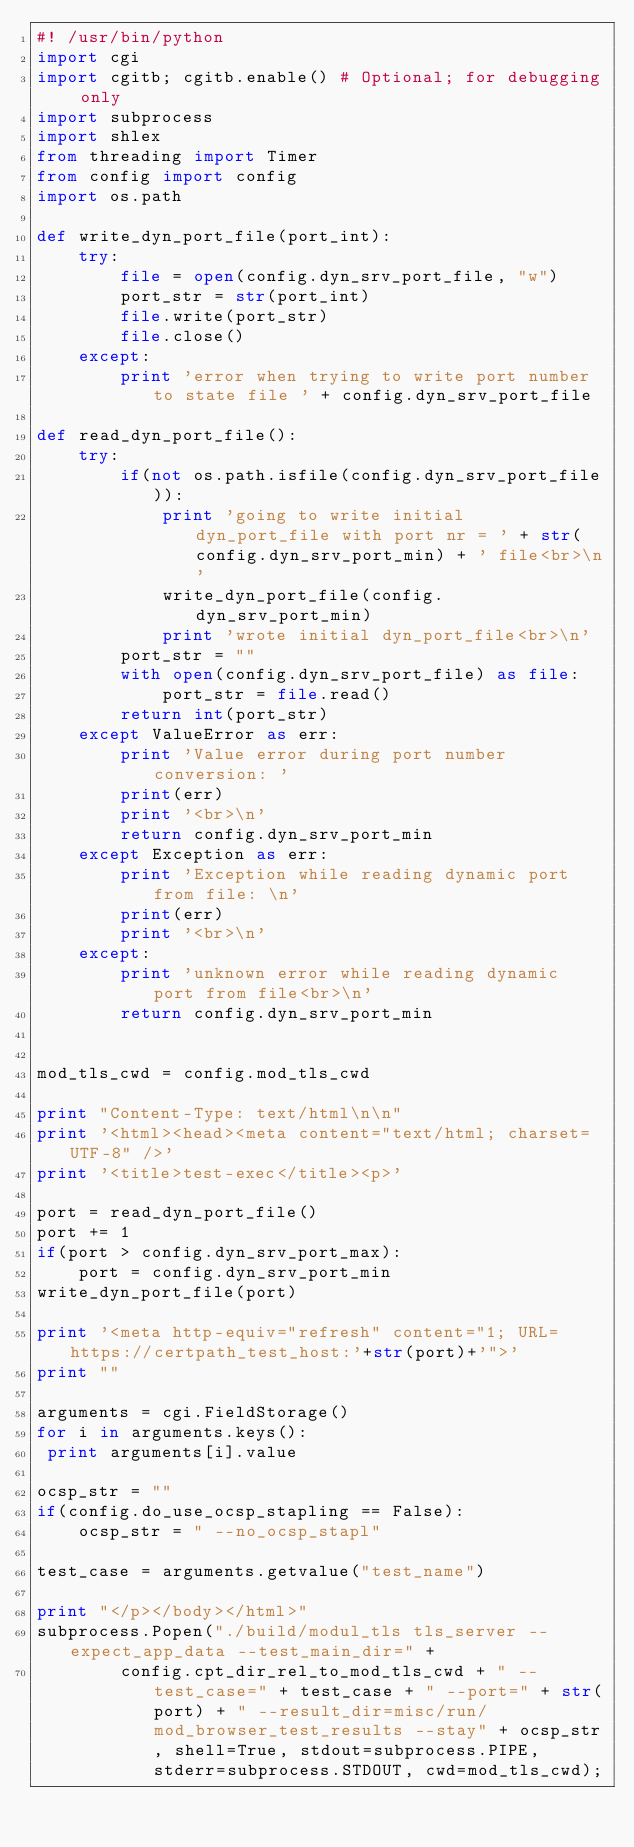<code> <loc_0><loc_0><loc_500><loc_500><_Python_>#! /usr/bin/python
import cgi
import cgitb; cgitb.enable() # Optional; for debugging only
import subprocess
import shlex
from threading import Timer
from config import config
import os.path

def write_dyn_port_file(port_int):
    try:
        file = open(config.dyn_srv_port_file, "w")
        port_str = str(port_int)
        file.write(port_str)
        file.close()
    except:
        print 'error when trying to write port number to state file ' + config.dyn_srv_port_file

def read_dyn_port_file():
    try:
        if(not os.path.isfile(config.dyn_srv_port_file)):
            print 'going to write initial dyn_port_file with port nr = ' + str(config.dyn_srv_port_min) + ' file<br>\n'
            write_dyn_port_file(config.dyn_srv_port_min)
            print 'wrote initial dyn_port_file<br>\n'
        port_str = ""
        with open(config.dyn_srv_port_file) as file:  
            port_str = file.read() 
        return int(port_str)
    except ValueError as err:
        print 'Value error during port number conversion: '
        print(err)
        print '<br>\n'
        return config.dyn_srv_port_min
    except Exception as err:
        print 'Exception while reading dynamic port from file: \n'
        print(err)
        print '<br>\n'
    except:
        print 'unknown error while reading dynamic port from file<br>\n'
        return config.dyn_srv_port_min
        

mod_tls_cwd = config.mod_tls_cwd

print "Content-Type: text/html\n\n"
print '<html><head><meta content="text/html; charset=UTF-8" />'
print '<title>test-exec</title><p>'

port = read_dyn_port_file()
port += 1
if(port > config.dyn_srv_port_max):
    port = config.dyn_srv_port_min
write_dyn_port_file(port)

print '<meta http-equiv="refresh" content="1; URL=https://certpath_test_host:'+str(port)+'">'
print ""

arguments = cgi.FieldStorage()
for i in arguments.keys():
 print arguments[i].value

ocsp_str = ""
if(config.do_use_ocsp_stapling == False):
    ocsp_str = " --no_ocsp_stapl"
 
test_case = arguments.getvalue("test_name")

print "</p></body></html>"
subprocess.Popen("./build/modul_tls tls_server --expect_app_data --test_main_dir=" +
        config.cpt_dir_rel_to_mod_tls_cwd + " --test_case=" + test_case + " --port=" + str(port) + " --result_dir=misc/run/mod_browser_test_results --stay" + ocsp_str, shell=True, stdout=subprocess.PIPE, stderr=subprocess.STDOUT, cwd=mod_tls_cwd);

</code> 